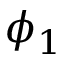<formula> <loc_0><loc_0><loc_500><loc_500>\phi _ { 1 }</formula> 